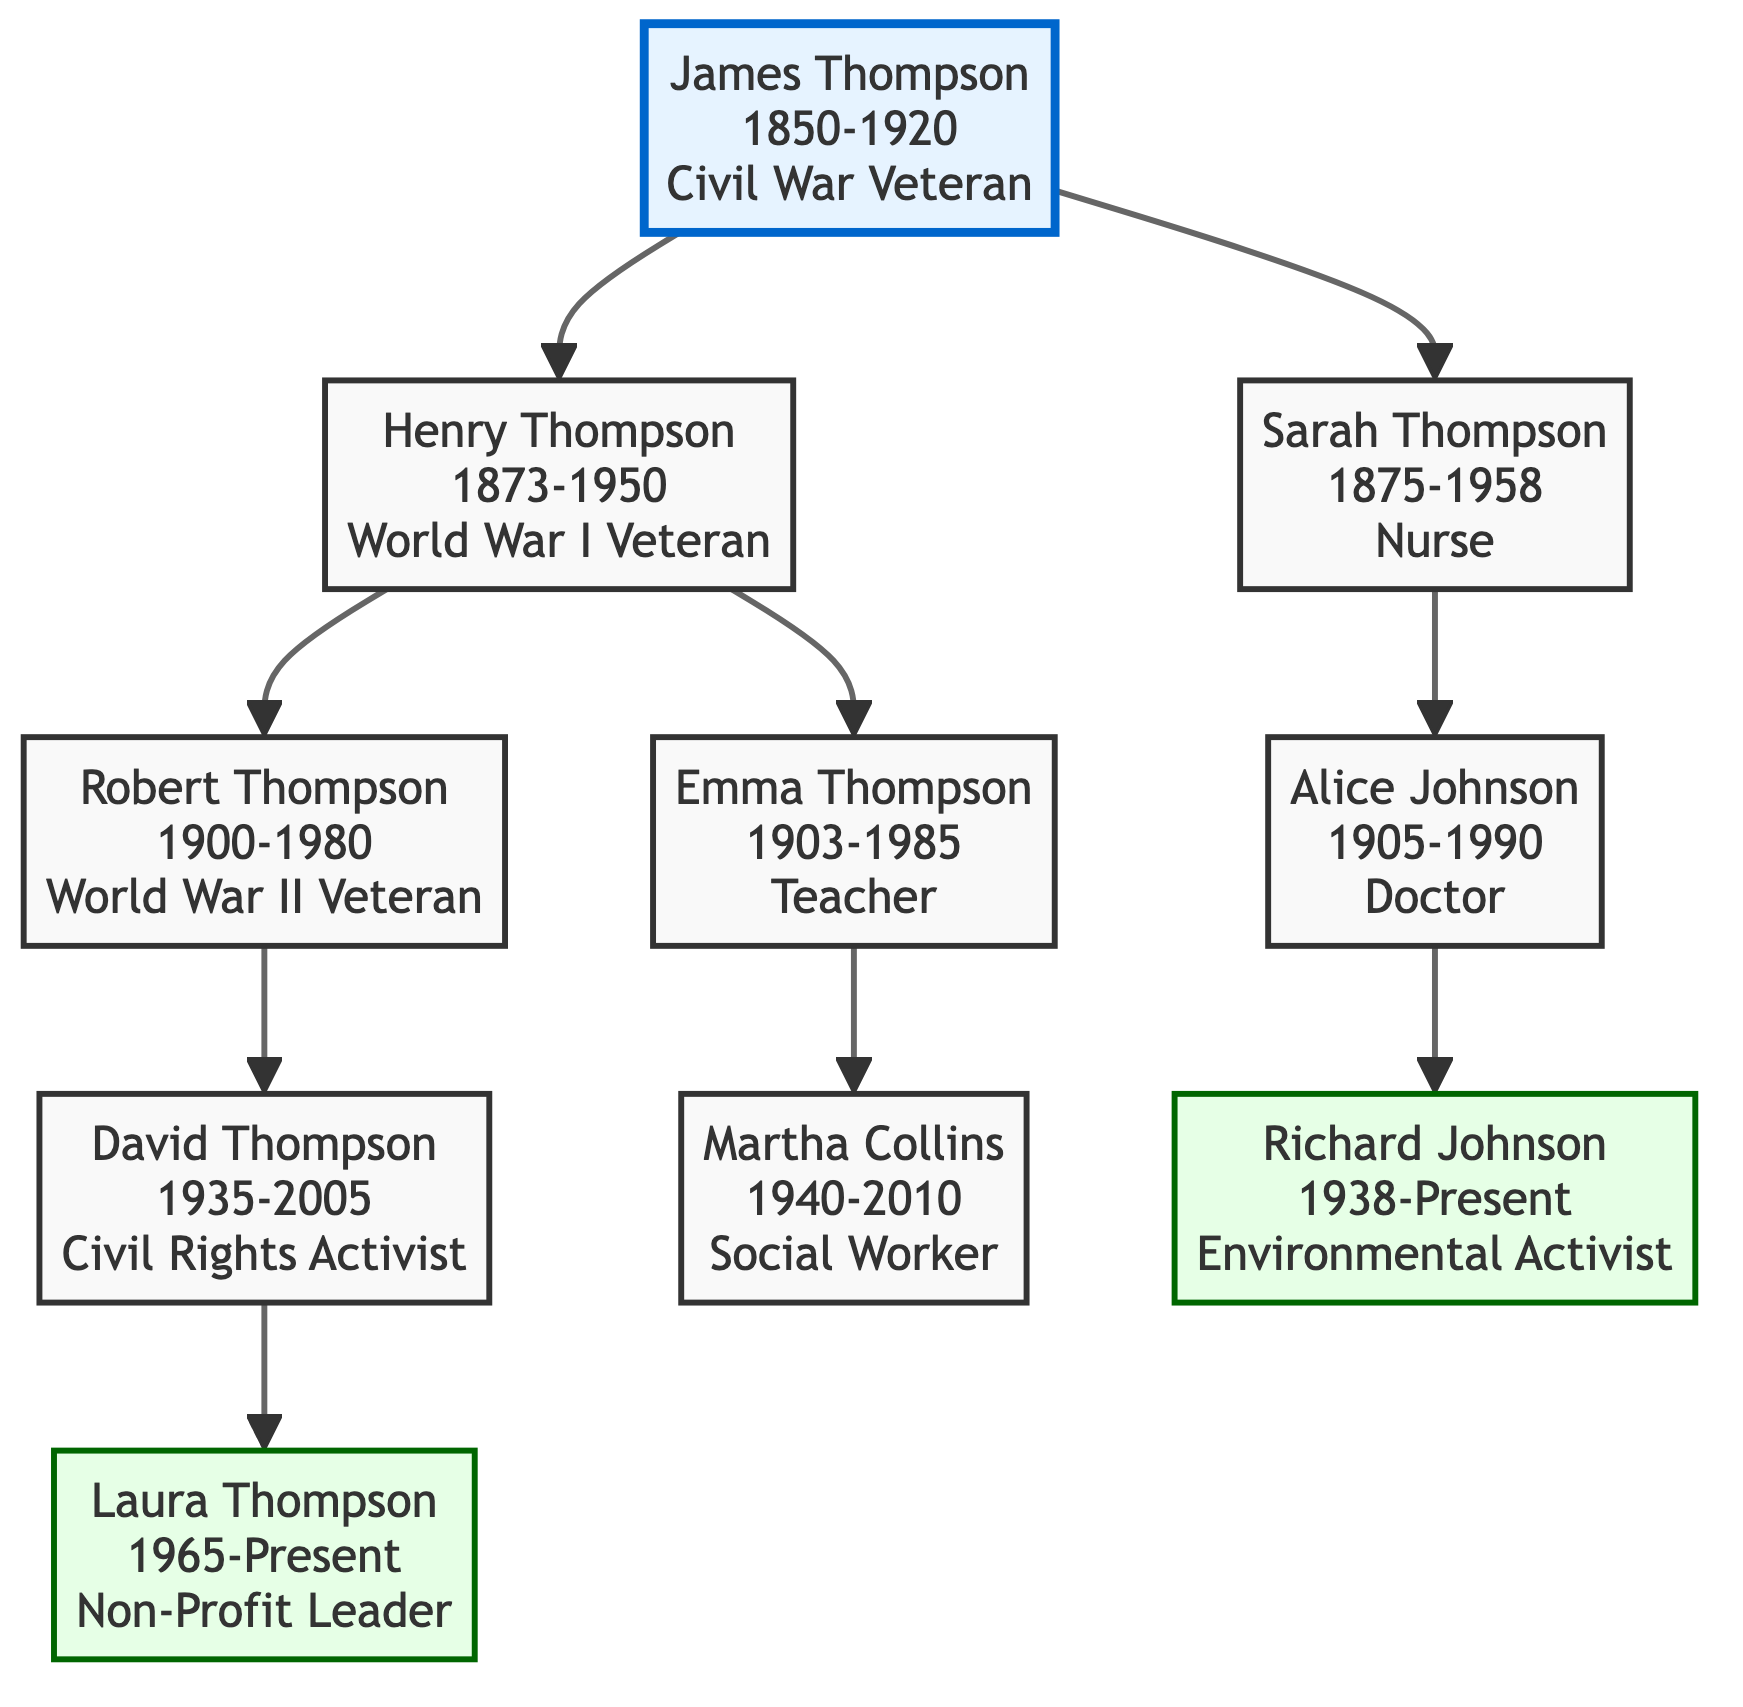What is the birth year of James Thompson? The diagram indicates that James Thompson was born in the year 1850. This information is directly stated in his node.
Answer: 1850 How many children did Henry Thompson have? By examining Henry Thompson's section, we see that he has two children listed: Robert Thompson and Emma Thompson. Therefore, the answer is derived from counting the children in his node.
Answer: 2 Which role did Sarah Thompson hold? The node associated with Sarah Thompson specifies her role as a Nurse. This information is explicitly mentioned.
Answer: Nurse Who is the child of Robert Thompson? The diagram shows that Robert Thompson has one child, David Thompson. This information is contained within Robert's section of the tree.
Answer: David Thompson What significant role did David Thompson play? Looking at David Thompson's node, it describes him as a Civil Rights Activist, highlighting his contributions and significance within the community.
Answer: Civil Rights Activist Which family member established medical camps during World War II? The diagram clearly states that Sarah Thompson established medical camps for displaced families during World War II, providing a direct answer.
Answer: Sarah Thompson What is Richard Johnson's current role? The node for Richard Johnson indicates that he is an Environmental Activist, which is stated as his current role and focus.
Answer: Environmental Activist How many generations does the family tree encompass? Analyzing the tree, we can see that it extends from James Thompson, who is the first generation, down to Laura Thompson in the current generation. There are five generations represented in total.
Answer: 5 Who is the oldest family member shown in the diagram? By comparing the birth years of all family members, James Thompson, born in 1850, is the oldest member listed in the family tree.
Answer: James Thompson What community initiative did Emma Thompson inspire? The diagram notes that Emma Thompson taught community-driven initiatives in schools, emphasizing educational empowerment for future generations.
Answer: Community-driven initiatives 